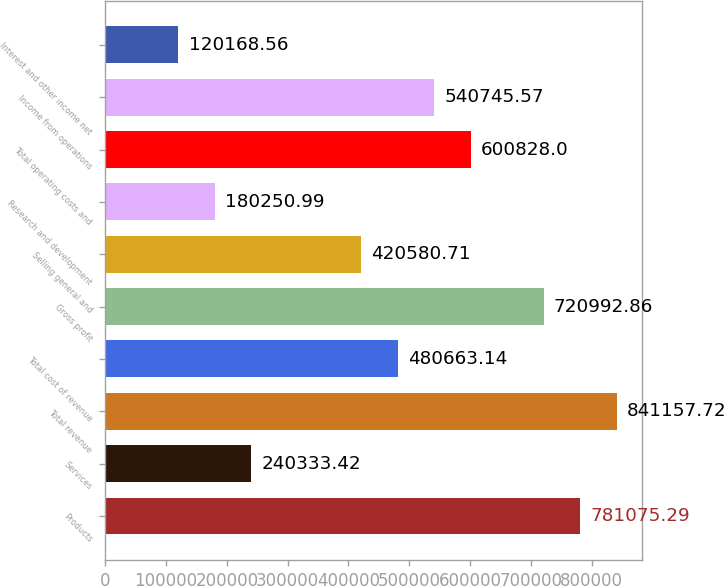Convert chart to OTSL. <chart><loc_0><loc_0><loc_500><loc_500><bar_chart><fcel>Products<fcel>Services<fcel>Total revenue<fcel>Total cost of revenue<fcel>Gross profit<fcel>Selling general and<fcel>Research and development<fcel>Total operating costs and<fcel>Income from operations<fcel>Interest and other income net<nl><fcel>781075<fcel>240333<fcel>841158<fcel>480663<fcel>720993<fcel>420581<fcel>180251<fcel>600828<fcel>540746<fcel>120169<nl></chart> 